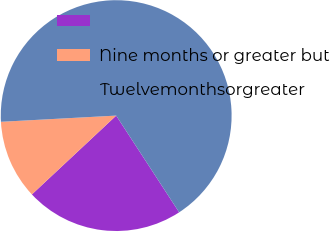Convert chart to OTSL. <chart><loc_0><loc_0><loc_500><loc_500><pie_chart><ecel><fcel>Nine months or greater but<fcel>Twelvemonthsorgreater<nl><fcel>22.22%<fcel>11.11%<fcel>66.67%<nl></chart> 